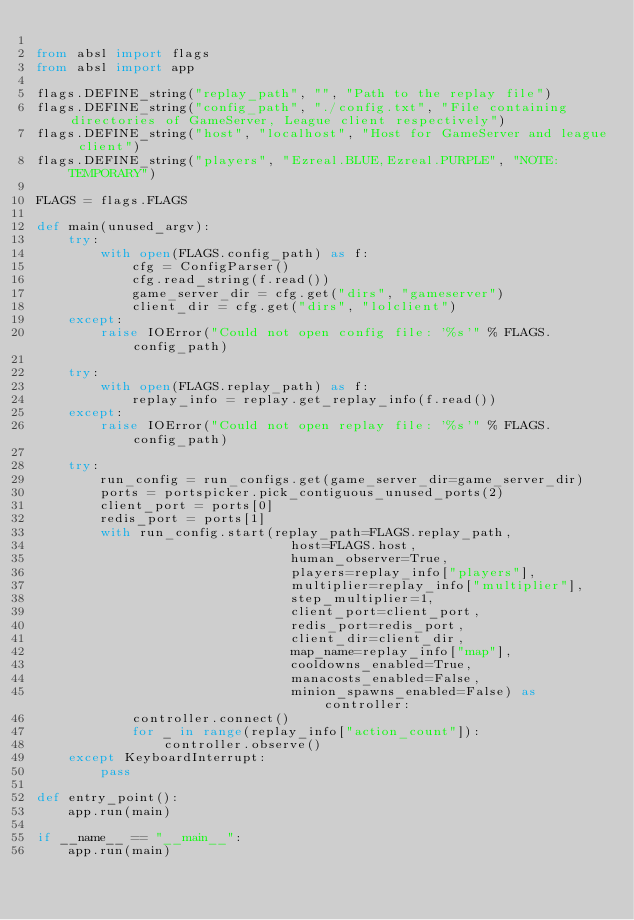<code> <loc_0><loc_0><loc_500><loc_500><_Python_>
from absl import flags
from absl import app

flags.DEFINE_string("replay_path", "", "Path to the replay file")
flags.DEFINE_string("config_path", "./config.txt", "File containing directories of GameServer, League client respectively")
flags.DEFINE_string("host", "localhost", "Host for GameServer and league client")
flags.DEFINE_string("players", "Ezreal.BLUE,Ezreal.PURPLE", "NOTE: TEMPORARY")

FLAGS = flags.FLAGS

def main(unused_argv):
    try:
        with open(FLAGS.config_path) as f:
            cfg = ConfigParser()
            cfg.read_string(f.read())
            game_server_dir = cfg.get("dirs", "gameserver")
            client_dir = cfg.get("dirs", "lolclient")
    except:
        raise IOError("Could not open config file: '%s'" % FLAGS.config_path)

    try:
        with open(FLAGS.replay_path) as f:
            replay_info = replay.get_replay_info(f.read())
    except:
        raise IOError("Could not open replay file: '%s'" % FLAGS.config_path)

    try:
        run_config = run_configs.get(game_server_dir=game_server_dir)
        ports = portspicker.pick_contiguous_unused_ports(2)
        client_port = ports[0]
        redis_port = ports[1]
        with run_config.start(replay_path=FLAGS.replay_path,
                                host=FLAGS.host,
                                human_observer=True,
                                players=replay_info["players"],
                                multiplier=replay_info["multiplier"],
                                step_multiplier=1,
                                client_port=client_port,
                                redis_port=redis_port,
                                client_dir=client_dir,
                                map_name=replay_info["map"],
                                cooldowns_enabled=True,
                                manacosts_enabled=False,
                                minion_spawns_enabled=False) as controller:
            controller.connect()
            for _ in range(replay_info["action_count"]):
                controller.observe()
    except KeyboardInterrupt:
        pass

def entry_point():
    app.run(main)

if __name__ == "__main__":
    app.run(main)
</code> 